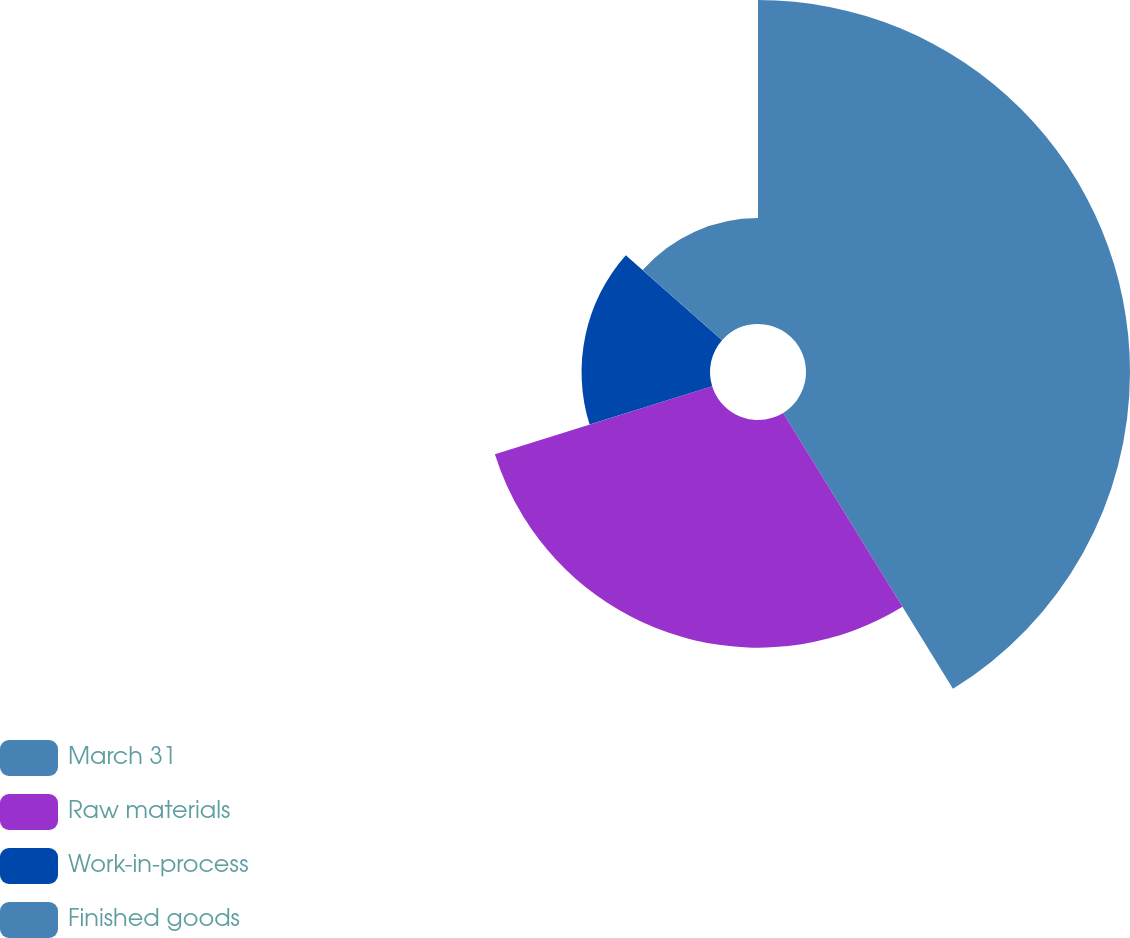<chart> <loc_0><loc_0><loc_500><loc_500><pie_chart><fcel>March 31<fcel>Raw materials<fcel>Work-in-process<fcel>Finished goods<nl><fcel>41.22%<fcel>28.96%<fcel>16.34%<fcel>13.48%<nl></chart> 